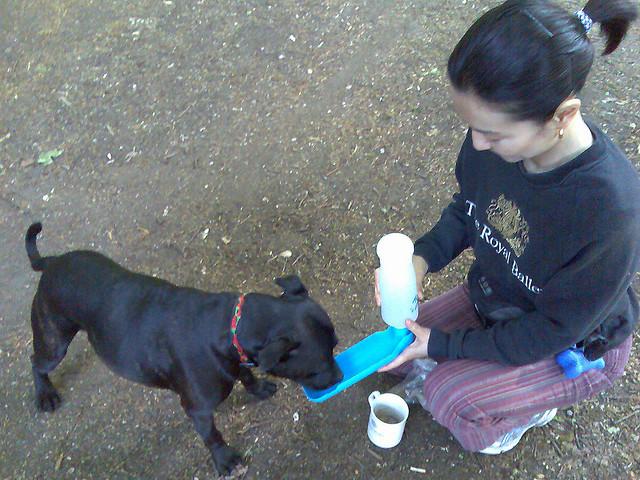What is the woman using to hold her hair back away from her face?
Answer briefly. Hair tie. Is the dog thirsty?
Give a very brief answer. Yes. Is this youngster on her way to becoming a loving adult with a penchant for sharing?
Give a very brief answer. Yes. 